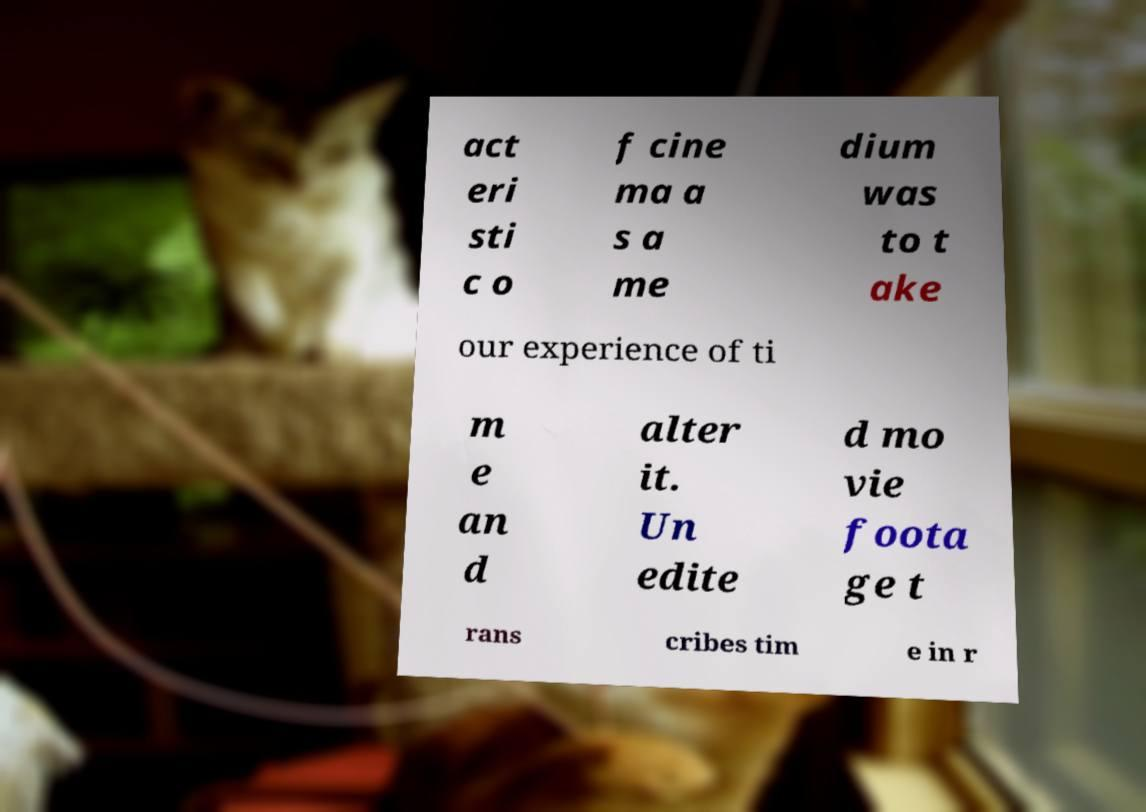Could you assist in decoding the text presented in this image and type it out clearly? act eri sti c o f cine ma a s a me dium was to t ake our experience of ti m e an d alter it. Un edite d mo vie foota ge t rans cribes tim e in r 